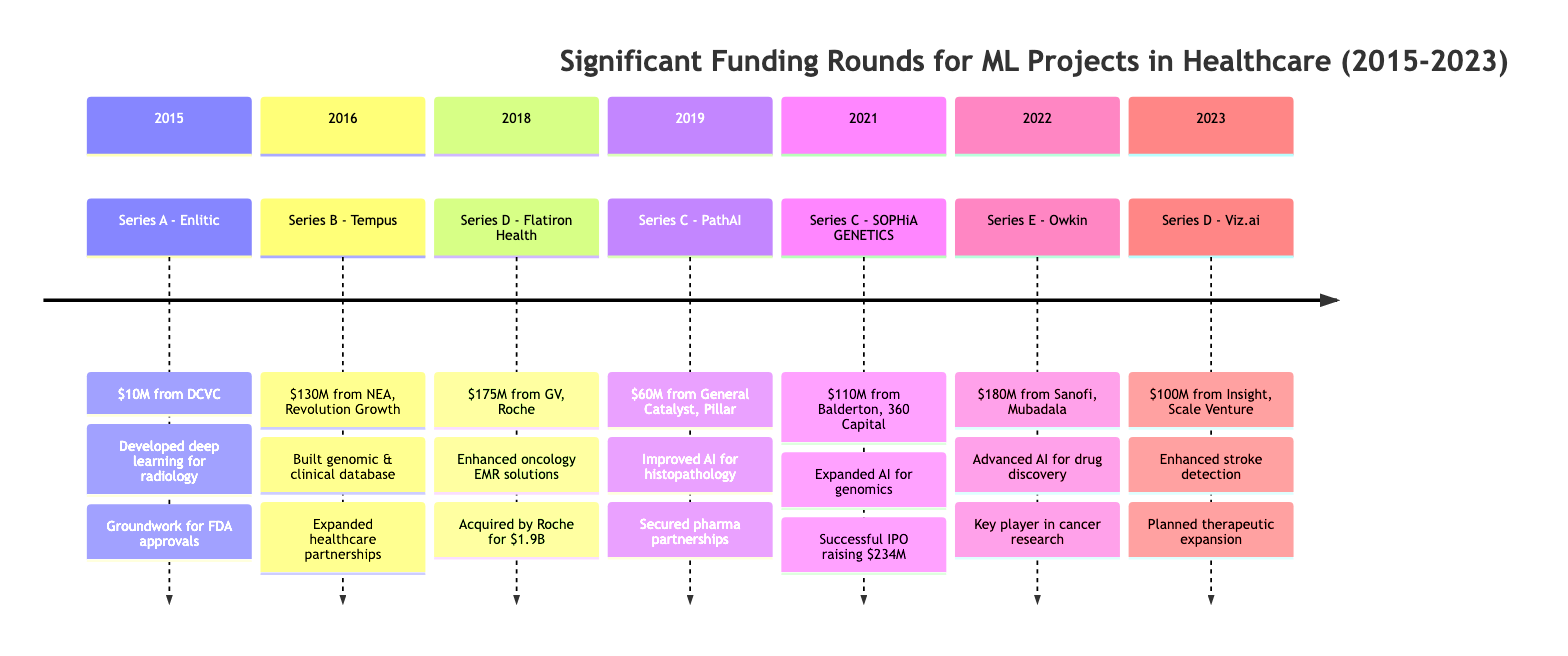What year did Enlitic receive funding? The diagram indicates that Enlitic received Series A funding in 2015.
Answer: 2015 What was the amount of funding for SOPHiA GENETICS? According to the diagram, SOPHiA GENETICS received $110 million in Series C funding.
Answer: $110 million Which event was associated with the highest funding amount? By reviewing the funding amounts in the timeline, the highest is $180 million for Owkin in 2022.
Answer: $180 million What source funded PathAI in 2019? The funding information for PathAI shows that General Catalyst and Pillar were the sources of its $60 million Series C funding.
Answer: General Catalyst, Pillar Which company was acquired by Roche? The timeline indicates that Flatiron Health, which received $175 million in funding in 2018, was acquired by Roche for $1.9 billion.
Answer: Flatiron Health How did the funding for Tempus in 2016 impact its partnerships? The diagram mentions that the funding allowed Tempus to expand its partnerships with major healthcare providers. Thus, the funding impacted its collaborations positively.
Answer: Expanded partnerships What was the outcome of the Series E funding for Owkin? The outcome stated in the timeline is that Owkin advanced its AI models for drug discovery and became a key player in cancer research.
Answer: Advanced AI models for drug discovery How many Series C funding events occurred between 2015 and 2023? A review of the timeline shows that there were three Series C funding events: PathAI in 2019 and SOPHiA GENETICS in 2021.
Answer: 2 What year did Flatiron Health receive funding? The timeline specifies that Flatiron Health received Series D funding in 2018.
Answer: 2018 